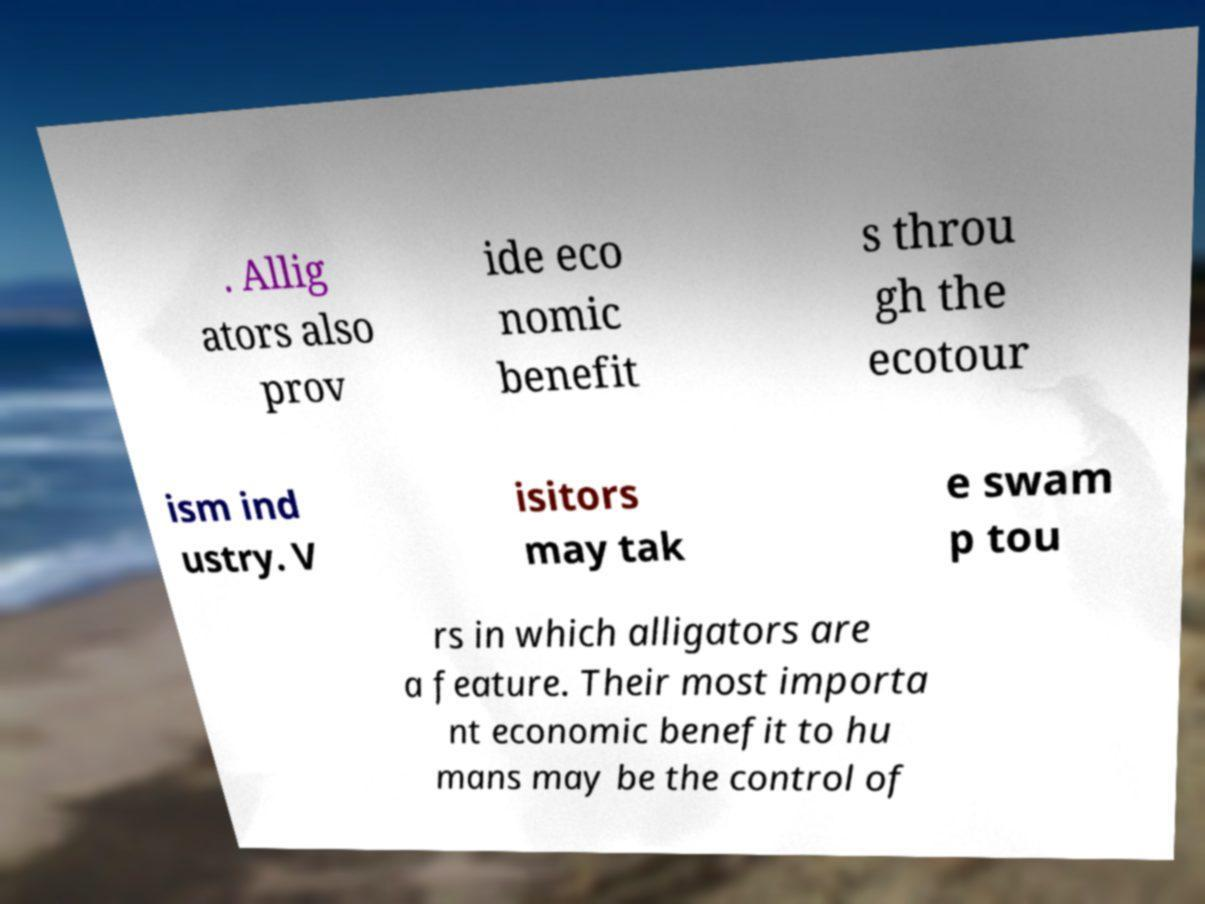Please read and relay the text visible in this image. What does it say? . Allig ators also prov ide eco nomic benefit s throu gh the ecotour ism ind ustry. V isitors may tak e swam p tou rs in which alligators are a feature. Their most importa nt economic benefit to hu mans may be the control of 